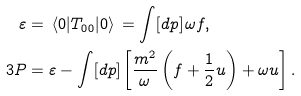Convert formula to latex. <formula><loc_0><loc_0><loc_500><loc_500>\varepsilon & = \, \langle 0 | T _ { 0 0 } | 0 \rangle \, = \int [ d p ] \, \omega f , \\ 3 P & = \varepsilon - \int [ d p ] \left [ \frac { m ^ { 2 } } { \omega } \left ( f + \frac { 1 } { 2 } u \right ) + \omega u \right ] .</formula> 